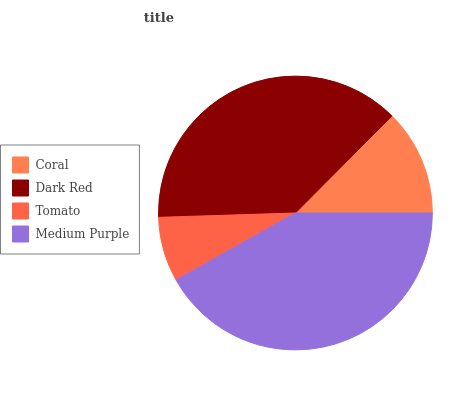Is Tomato the minimum?
Answer yes or no. Yes. Is Medium Purple the maximum?
Answer yes or no. Yes. Is Dark Red the minimum?
Answer yes or no. No. Is Dark Red the maximum?
Answer yes or no. No. Is Dark Red greater than Coral?
Answer yes or no. Yes. Is Coral less than Dark Red?
Answer yes or no. Yes. Is Coral greater than Dark Red?
Answer yes or no. No. Is Dark Red less than Coral?
Answer yes or no. No. Is Dark Red the high median?
Answer yes or no. Yes. Is Coral the low median?
Answer yes or no. Yes. Is Tomato the high median?
Answer yes or no. No. Is Medium Purple the low median?
Answer yes or no. No. 